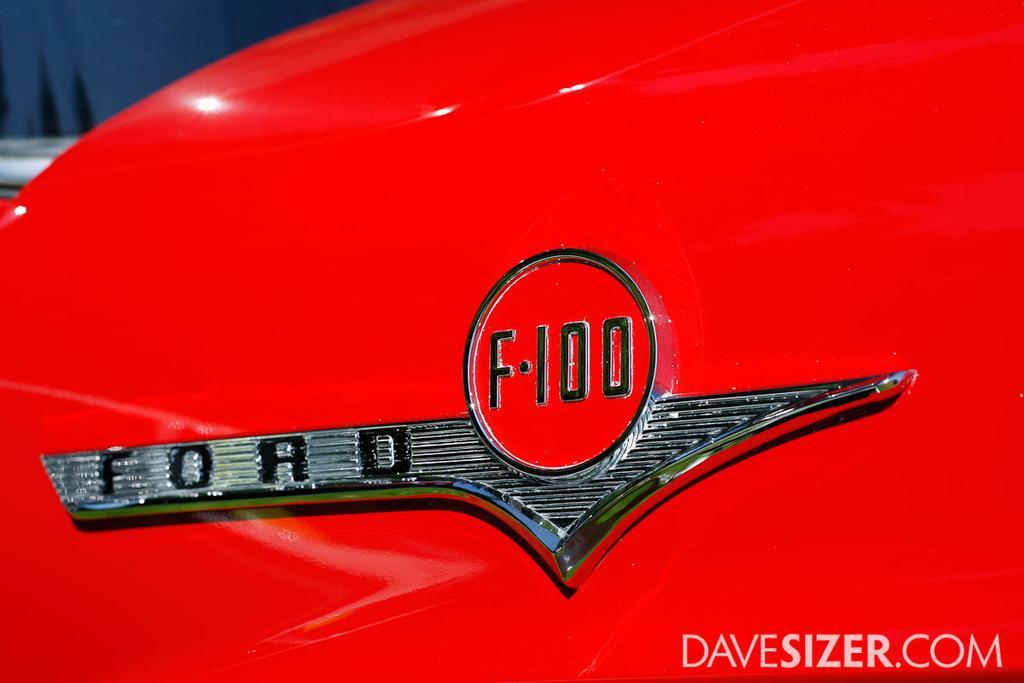Please provide a concise description of this image. In this image we can see the red color object and there is the logo and we can see the text written at the bottom of the picture. And there is the blur background. 